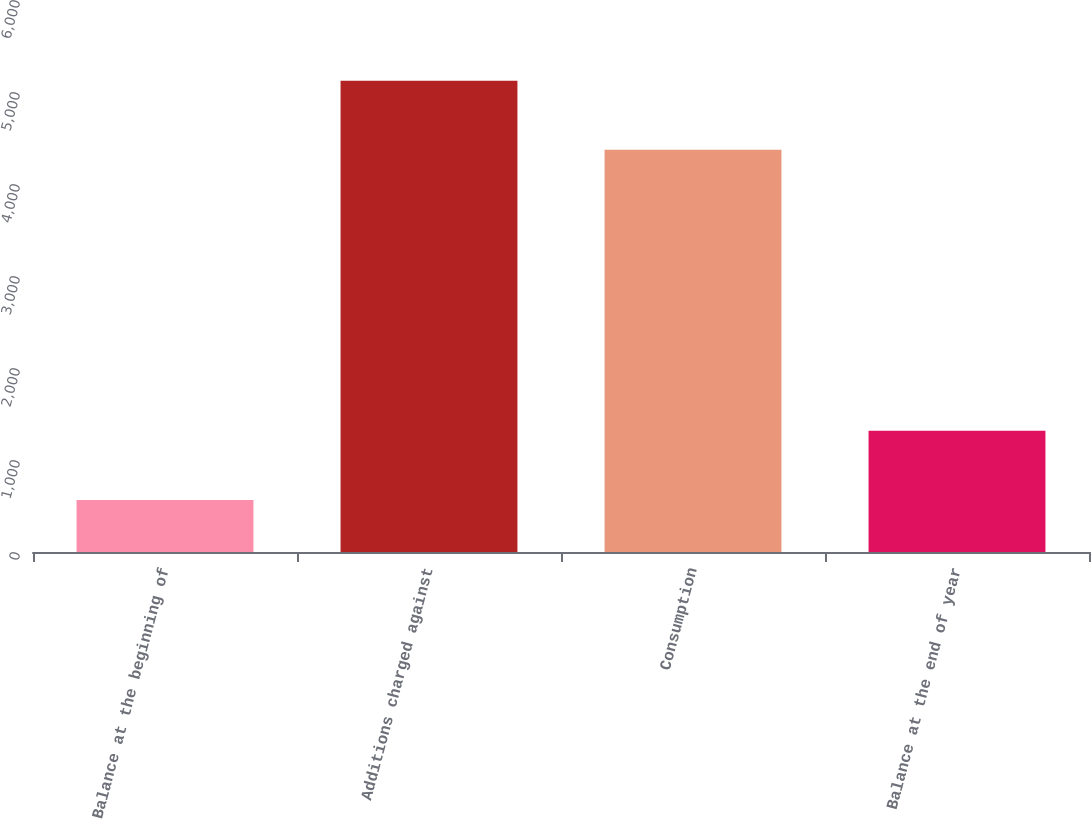<chart> <loc_0><loc_0><loc_500><loc_500><bar_chart><fcel>Balance at the beginning of<fcel>Additions charged against<fcel>Consumption<fcel>Balance at the end of year<nl><fcel>566<fcel>5122<fcel>4371<fcel>1317<nl></chart> 